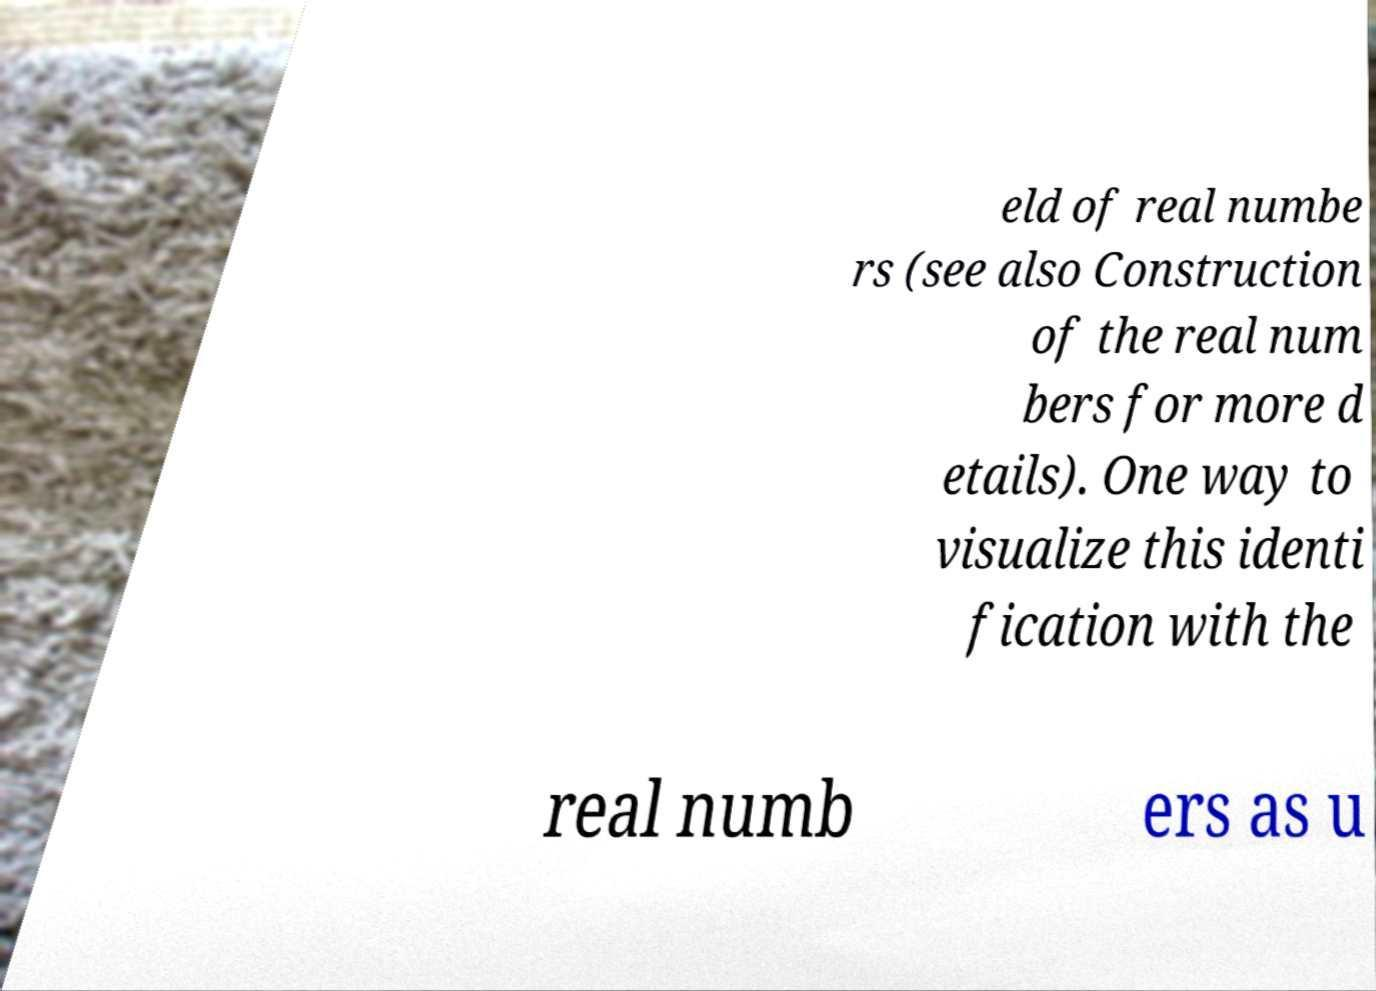What messages or text are displayed in this image? I need them in a readable, typed format. eld of real numbe rs (see also Construction of the real num bers for more d etails). One way to visualize this identi fication with the real numb ers as u 